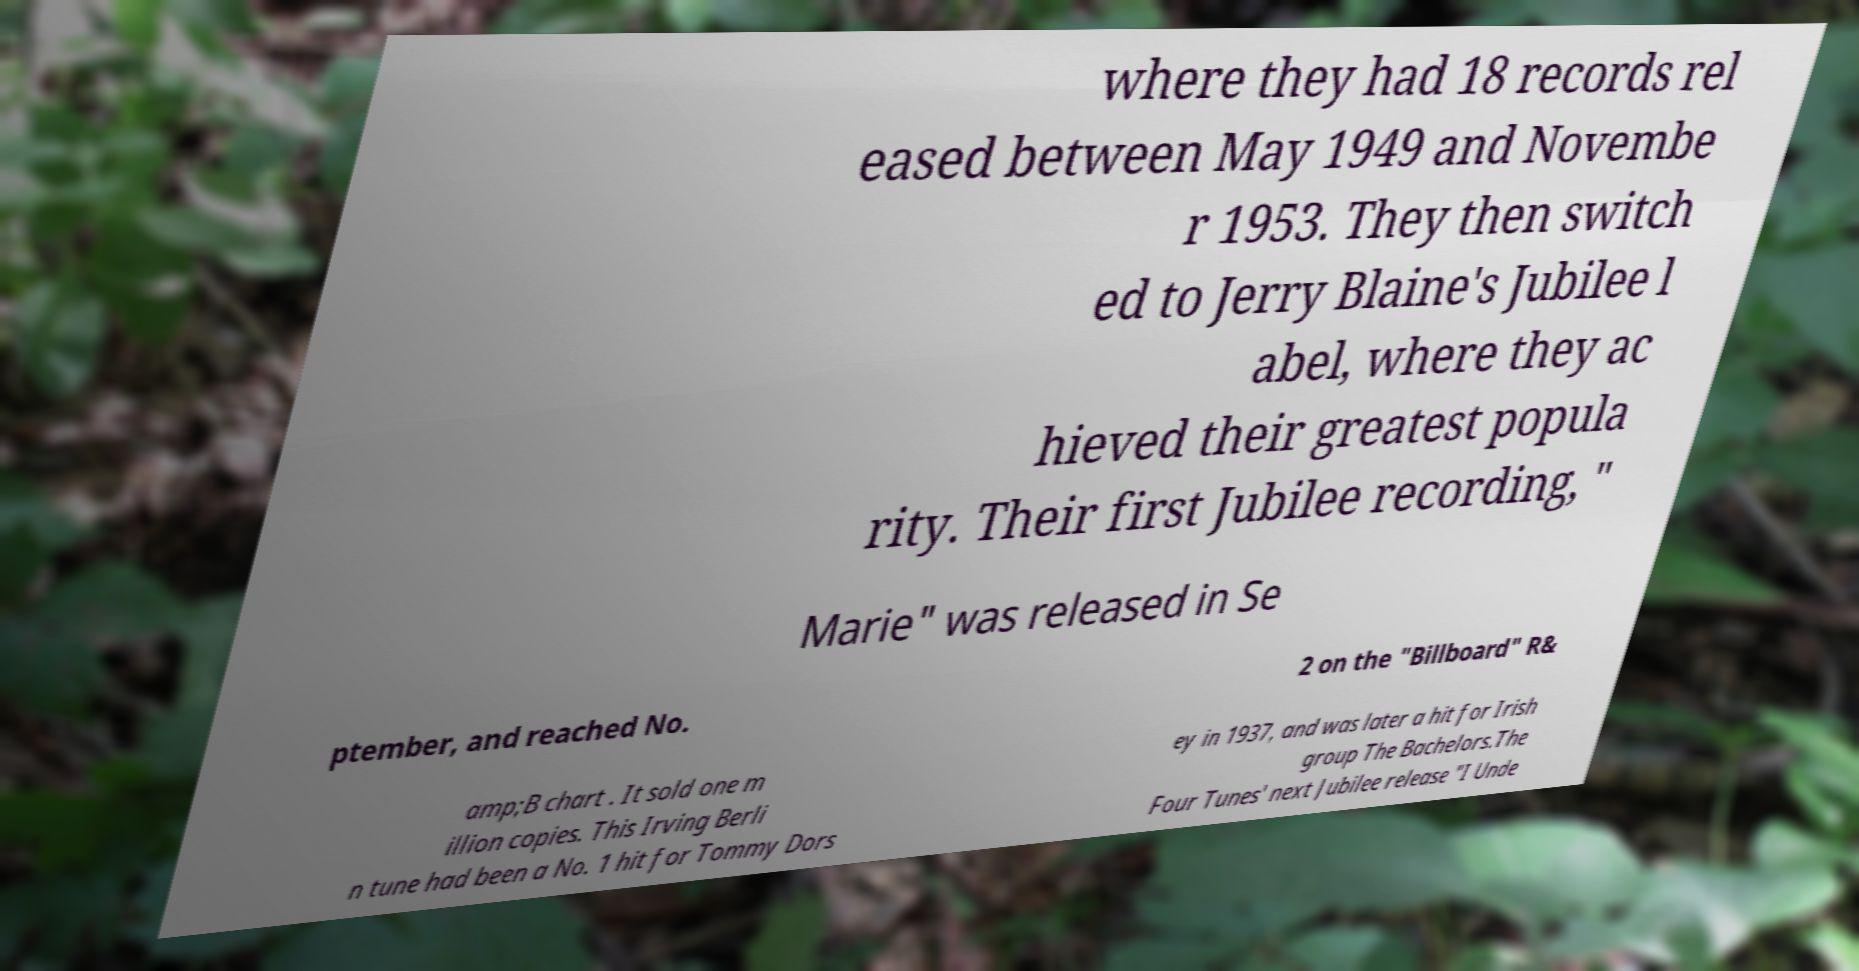Can you read and provide the text displayed in the image?This photo seems to have some interesting text. Can you extract and type it out for me? where they had 18 records rel eased between May 1949 and Novembe r 1953. They then switch ed to Jerry Blaine's Jubilee l abel, where they ac hieved their greatest popula rity. Their first Jubilee recording, " Marie" was released in Se ptember, and reached No. 2 on the "Billboard" R& amp;B chart . It sold one m illion copies. This Irving Berli n tune had been a No. 1 hit for Tommy Dors ey in 1937, and was later a hit for Irish group The Bachelors.The Four Tunes' next Jubilee release "I Unde 